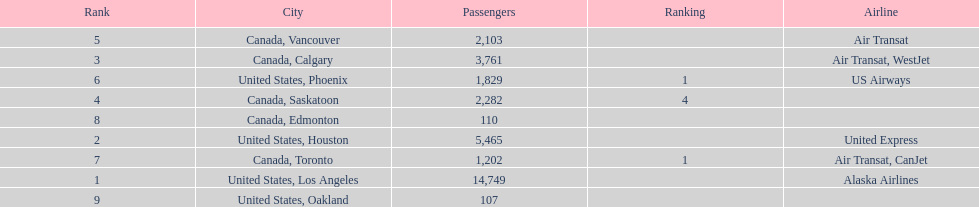Which canadian city had the most passengers traveling from manzanillo international airport in 2013? Calgary. 